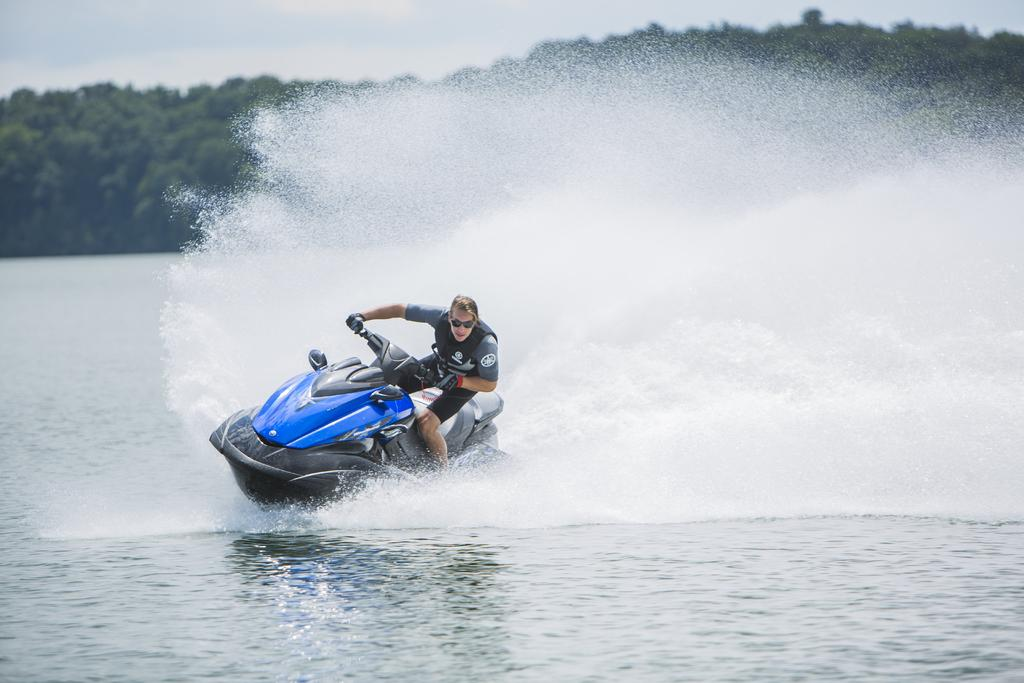What is the person in the image doing? There is a person riding a boat in the image. Where is the boat located? The boat is on the water. What can be seen in the background of the image? There are trees and the sky visible in the image. What is the condition of the sky in the image? The sky has clouds in it. What is present at the bottom of the image? Water is present at the bottom of the image. What type of approval does the person in the image need to continue their journey? There is no indication in the image that the person needs any approval to continue their journey. What type of plate is being used to serve the water in the image? There is no plate present in the image; water is visible at the bottom of the image. 